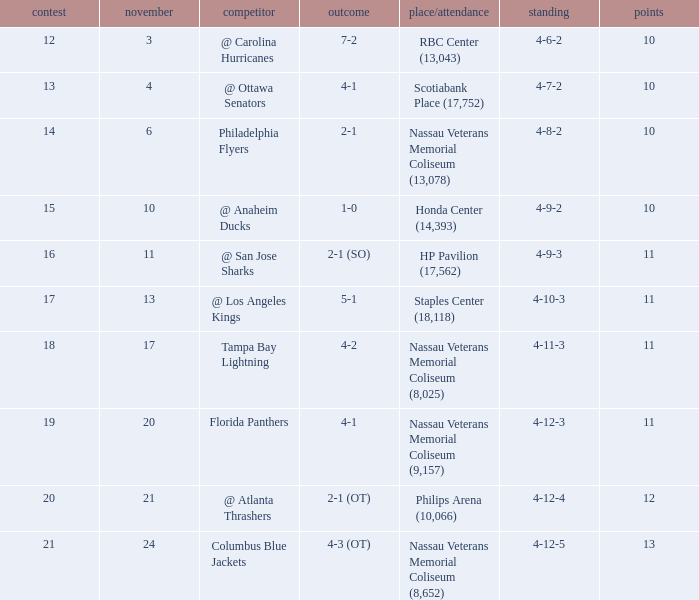What is the minimum requirement for entry if the score is 1-0? 15.0. 